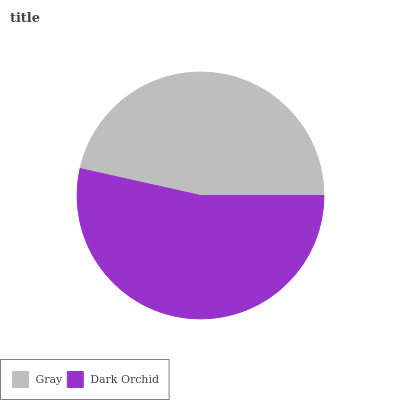Is Gray the minimum?
Answer yes or no. Yes. Is Dark Orchid the maximum?
Answer yes or no. Yes. Is Dark Orchid the minimum?
Answer yes or no. No. Is Dark Orchid greater than Gray?
Answer yes or no. Yes. Is Gray less than Dark Orchid?
Answer yes or no. Yes. Is Gray greater than Dark Orchid?
Answer yes or no. No. Is Dark Orchid less than Gray?
Answer yes or no. No. Is Dark Orchid the high median?
Answer yes or no. Yes. Is Gray the low median?
Answer yes or no. Yes. Is Gray the high median?
Answer yes or no. No. Is Dark Orchid the low median?
Answer yes or no. No. 